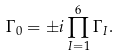<formula> <loc_0><loc_0><loc_500><loc_500>\Gamma _ { 0 } = \pm i \prod _ { I = 1 } ^ { 6 } \Gamma _ { I } .</formula> 